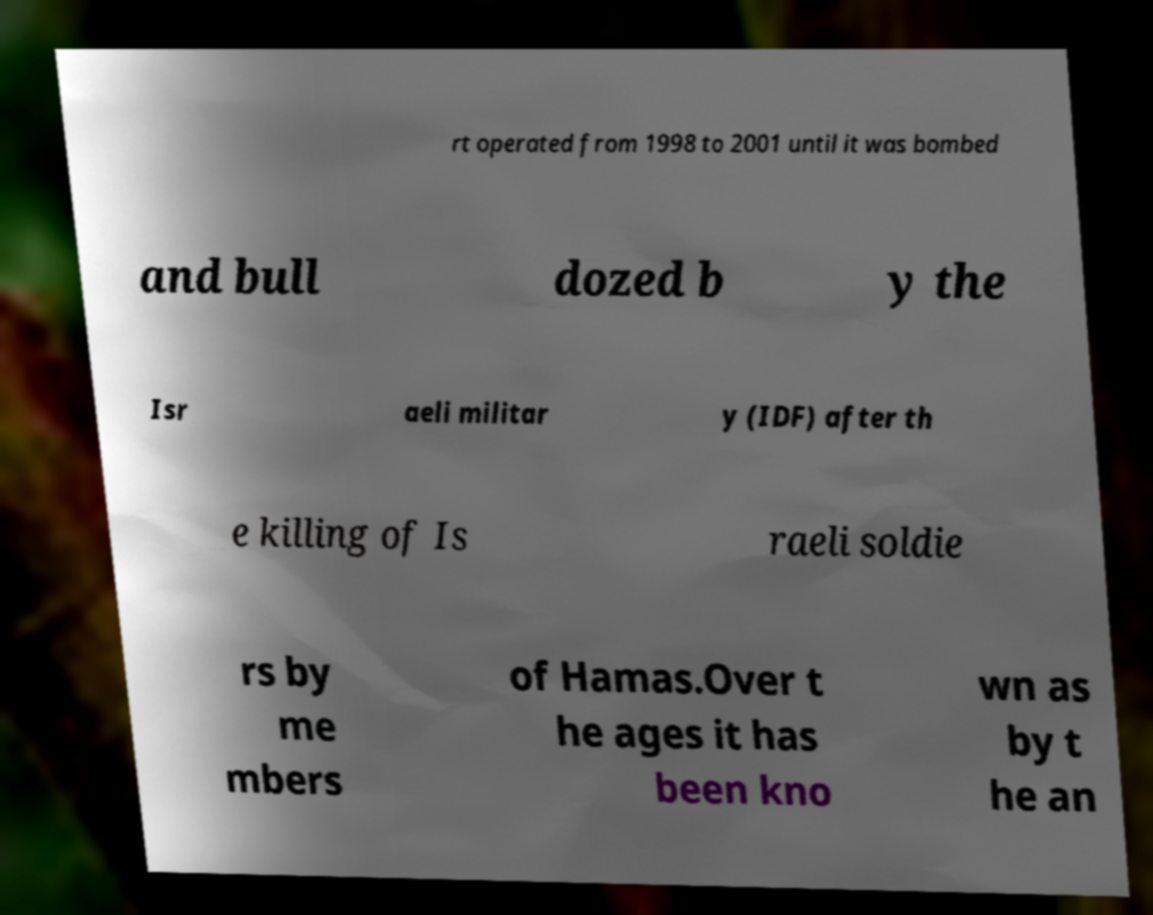Could you extract and type out the text from this image? rt operated from 1998 to 2001 until it was bombed and bull dozed b y the Isr aeli militar y (IDF) after th e killing of Is raeli soldie rs by me mbers of Hamas.Over t he ages it has been kno wn as by t he an 